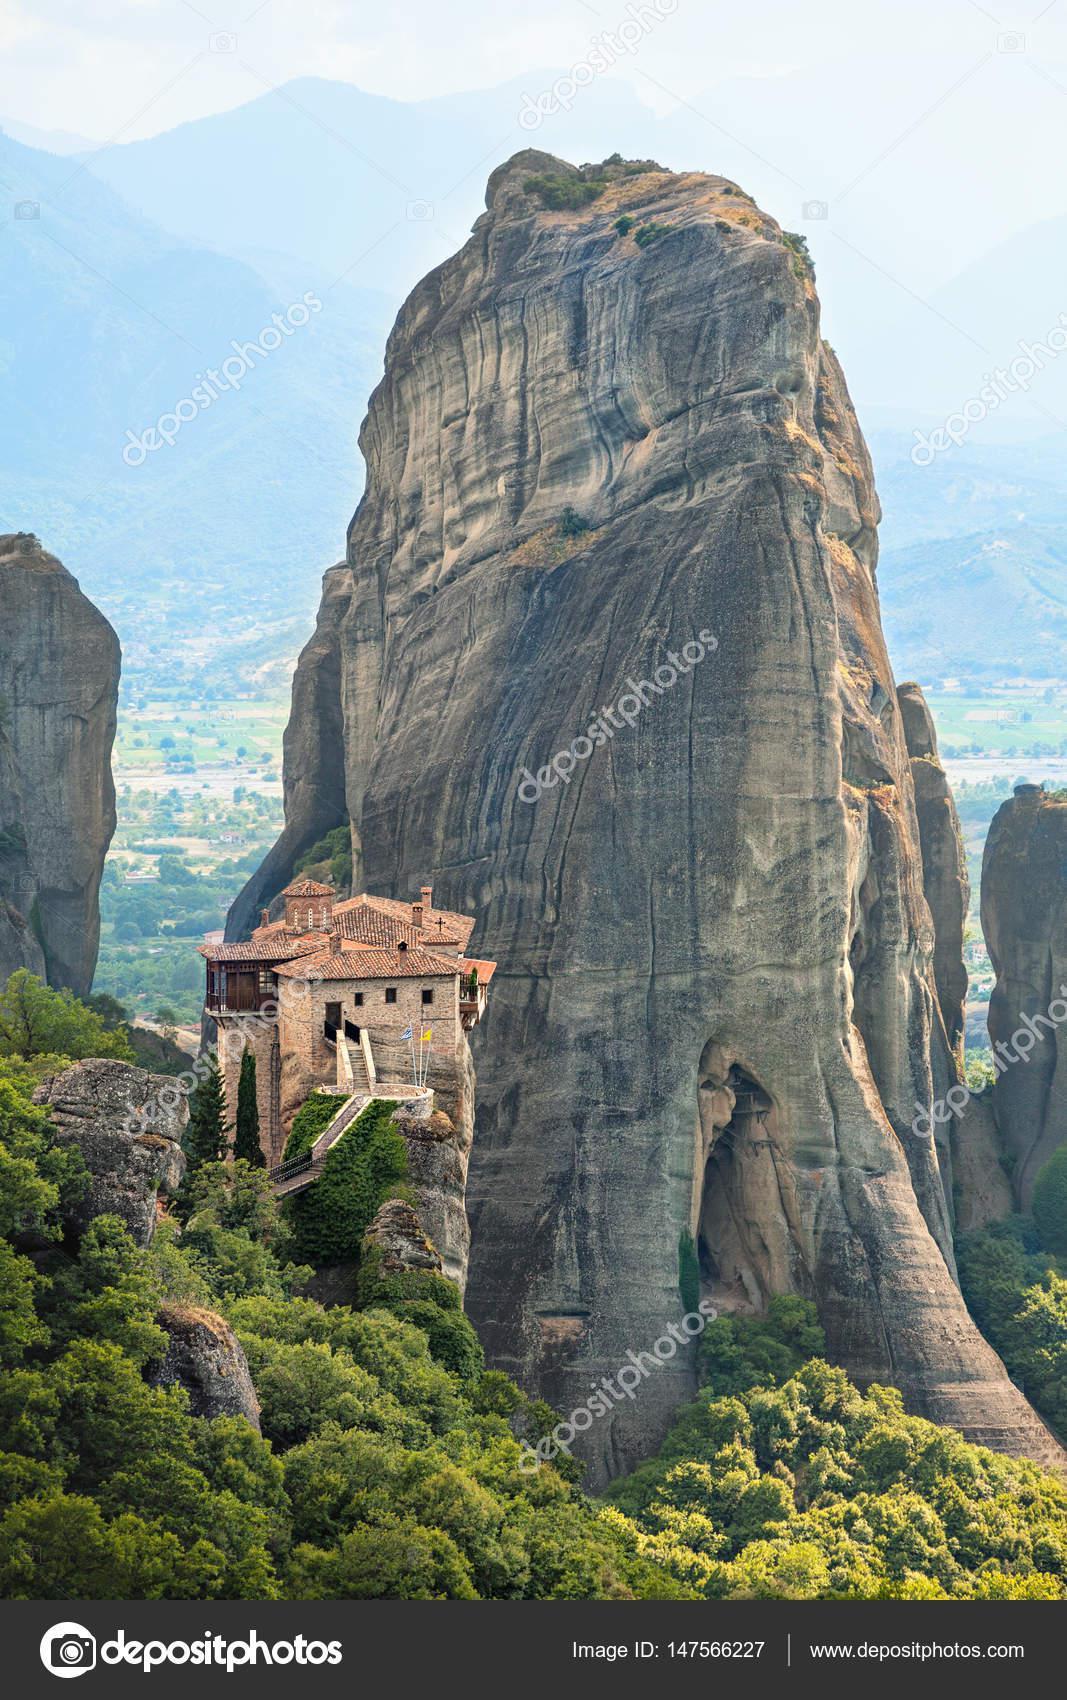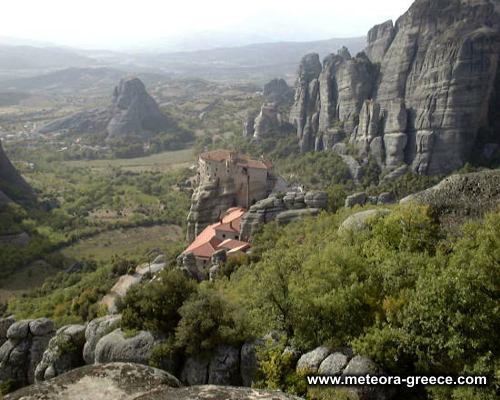The first image is the image on the left, the second image is the image on the right. Given the left and right images, does the statement "There is a wall surrounding some buildings." hold true? Answer yes or no. No. The first image is the image on the left, the second image is the image on the right. For the images displayed, is the sentence "In at least one image there is a peach building built in to the top of the rocks with one tower that is topped with a open wooden balcony." factually correct? Answer yes or no. No. 